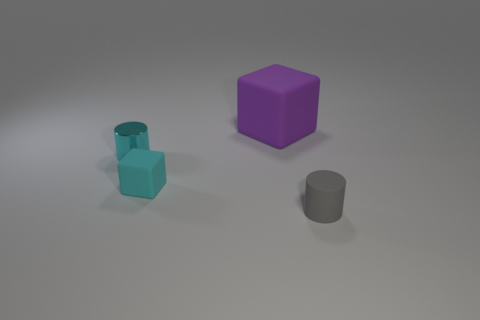How many cubes are large matte objects or matte things?
Your response must be concise. 2. Are there any gray rubber objects behind the tiny thing in front of the tiny rubber object that is behind the gray rubber cylinder?
Your answer should be compact. No. What color is the other tiny object that is the same shape as the small cyan shiny thing?
Offer a terse response. Gray. What number of yellow objects are either big metal balls or tiny cylinders?
Ensure brevity in your answer.  0. What material is the cyan thing that is left of the small rubber thing on the left side of the big object made of?
Ensure brevity in your answer.  Metal. Do the big rubber thing and the tiny shiny thing have the same shape?
Your answer should be very brief. No. What is the color of the metallic cylinder that is the same size as the cyan cube?
Your answer should be very brief. Cyan. Are there any tiny blocks of the same color as the large cube?
Offer a very short reply. No. Is there a small metal cylinder?
Ensure brevity in your answer.  Yes. Are the object in front of the small cyan matte object and the small cyan block made of the same material?
Make the answer very short. Yes. 